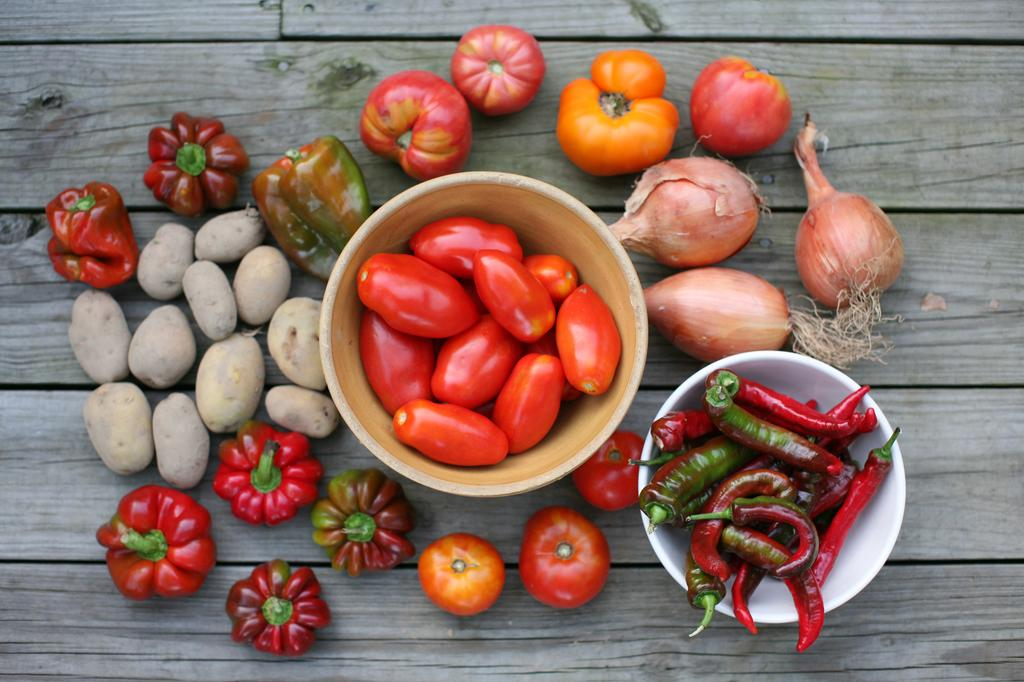What is in the bowl that is visible in the image? There is a bowl containing chilies and tomatoes in the image. What other vegetables can be seen in the image? Onions, capsicum, and potatoes are visible in the image. Are there any additional tomatoes in the image? Yes, additional tomatoes are on a table in the image. What type of sign can be seen on the van in the image? There is no van present in the image; it only features vegetables and a table. Is there a sink visible in the image? No, there is no sink present in the image. 